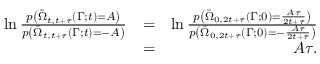Convert formula to latex. <formula><loc_0><loc_0><loc_500><loc_500>\begin{array} { r l r } { \ln \frac { p \left ( \bar { \Omega } _ { t , t + \tau } ( \Gamma ; t ) = A \right ) } { p \left ( \bar { \Omega } _ { t , t + \tau } ( \Gamma ; t ) = - A \right ) } } & { = } & { \ln \frac { p \left ( \bar { \Omega } _ { 0 , 2 t + \tau } ( \Gamma ; 0 ) = \frac { A \tau } { 2 t + \tau } \right ) } { p \left ( \bar { \Omega } _ { 0 , 2 t + \tau } ( \Gamma ; 0 ) = - \frac { A \tau } { 2 t + \tau } \right ) } } \\ & { = } & { A \tau . } \end{array}</formula> 